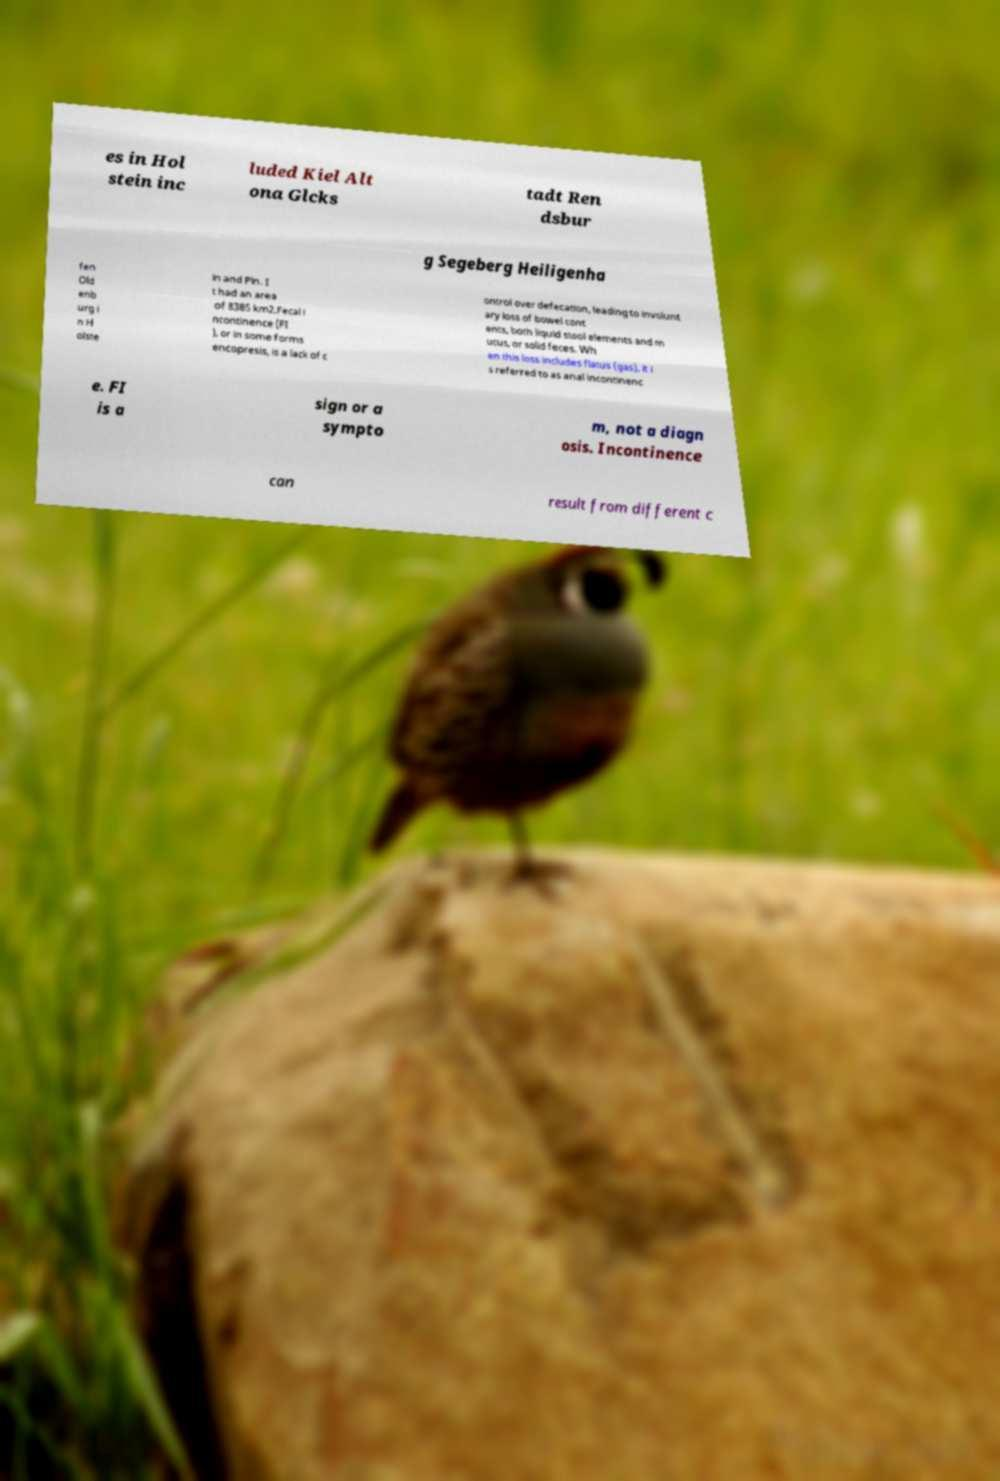Please identify and transcribe the text found in this image. es in Hol stein inc luded Kiel Alt ona Glcks tadt Ren dsbur g Segeberg Heiligenha fen Old enb urg i n H olste in and Pln. I t had an area of 8385 km2.Fecal i ncontinence (FI ), or in some forms encopresis, is a lack of c ontrol over defecation, leading to involunt ary loss of bowel cont ents, both liquid stool elements and m ucus, or solid feces. Wh en this loss includes flatus (gas), it i s referred to as anal incontinenc e. FI is a sign or a sympto m, not a diagn osis. Incontinence can result from different c 